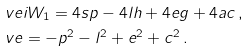Convert formula to latex. <formula><loc_0><loc_0><loc_500><loc_500>& \ v e i W _ { 1 } = 4 s p - 4 l h + 4 e g + 4 a c \, , \\ & \ v e = - p ^ { 2 } - l ^ { 2 } + e ^ { 2 } + c ^ { 2 } \, .</formula> 